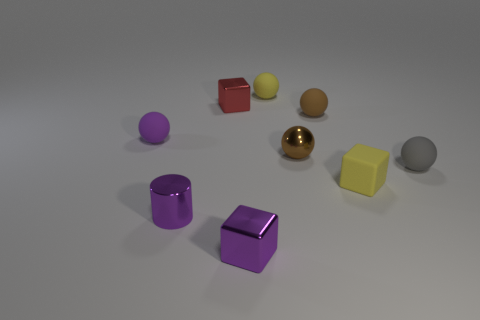Subtract 1 spheres. How many spheres are left? 4 Subtract all purple spheres. How many spheres are left? 4 Subtract all yellow balls. How many balls are left? 4 Subtract all red spheres. Subtract all red cubes. How many spheres are left? 5 Add 1 blue shiny balls. How many objects exist? 10 Subtract all cubes. How many objects are left? 6 Add 2 yellow rubber objects. How many yellow rubber objects exist? 4 Subtract 0 cyan spheres. How many objects are left? 9 Subtract all tiny purple balls. Subtract all metal objects. How many objects are left? 4 Add 3 brown metal things. How many brown metal things are left? 4 